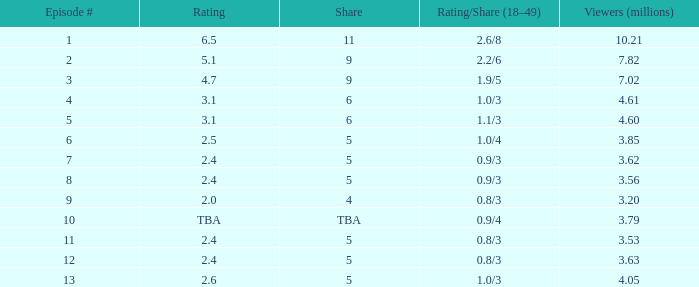For episodes before episode 5 with a 1.1/3 rating/share, what is the minimum number of million viewers? None. 